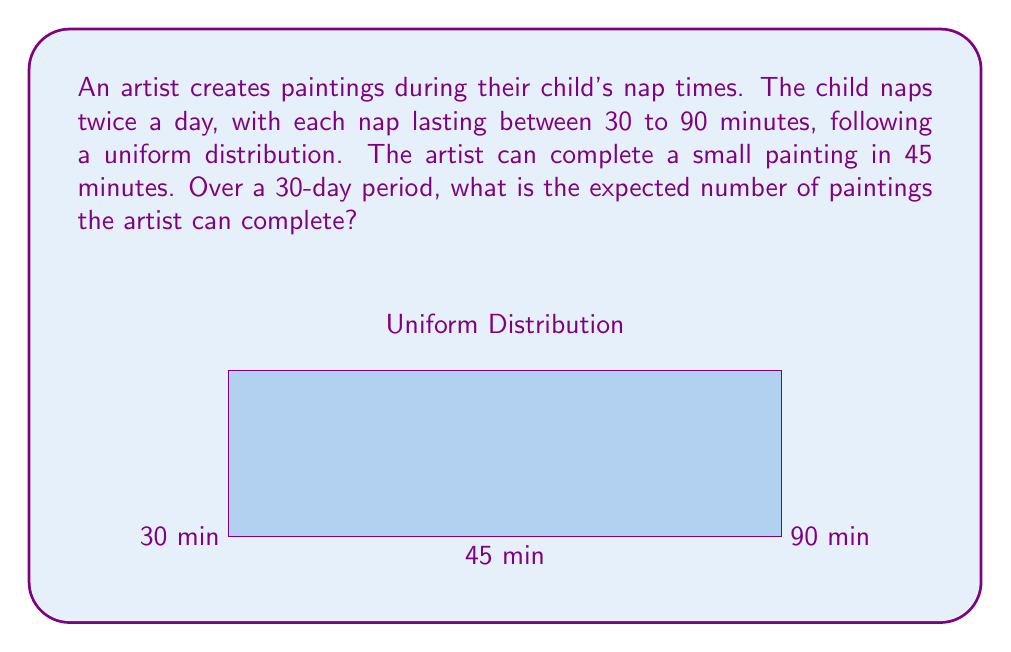What is the answer to this math problem? Let's approach this step-by-step:

1) First, we need to find the expected duration of each nap:
   $$E(\text{nap duration}) = \frac{30 + 90}{2} = 60 \text{ minutes}$$

2) The artist can complete a painting in 45 minutes. Let's calculate the expected number of paintings per nap:
   $$E(\text{paintings per nap}) = \frac{60}{45} = \frac{4}{3}$$

3) There are two naps per day, so the expected number of paintings per day is:
   $$E(\text{paintings per day}) = 2 \cdot \frac{4}{3} = \frac{8}{3}$$

4) Over a 30-day period, the expected number of paintings is:
   $$E(\text{paintings in 30 days}) = 30 \cdot \frac{8}{3} = 80$$

Therefore, over a 30-day period, the artist can expect to complete 80 paintings.
Answer: 80 paintings 